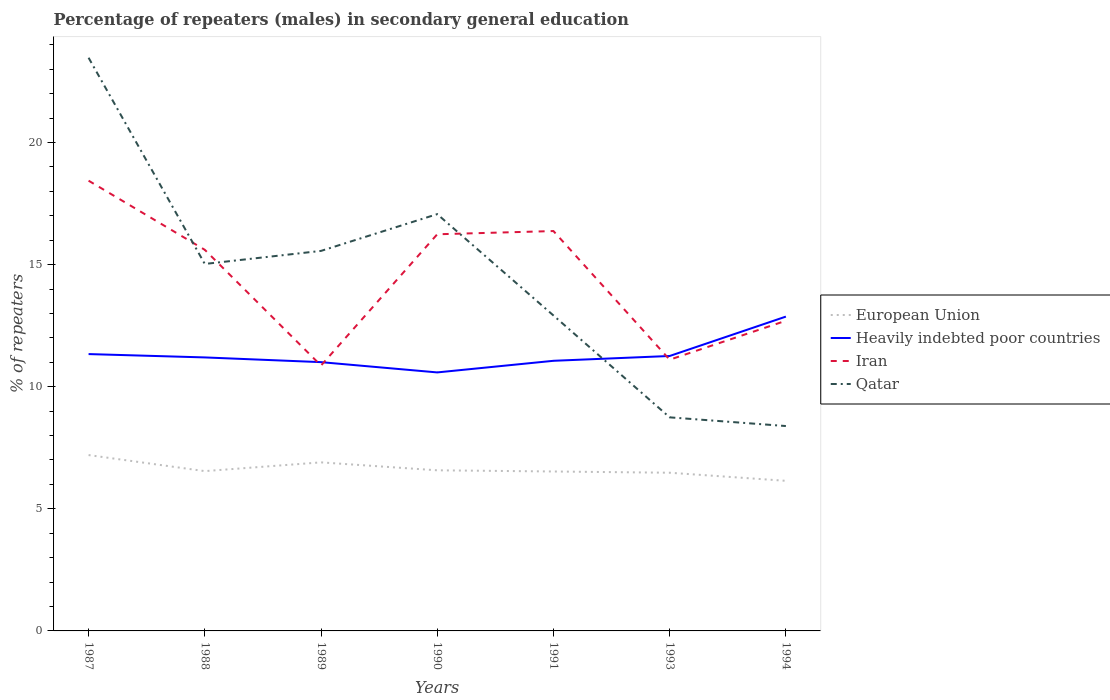How many different coloured lines are there?
Offer a very short reply. 4. Is the number of lines equal to the number of legend labels?
Make the answer very short. Yes. Across all years, what is the maximum percentage of male repeaters in Heavily indebted poor countries?
Give a very brief answer. 10.58. What is the total percentage of male repeaters in Heavily indebted poor countries in the graph?
Your answer should be very brief. 0.33. What is the difference between the highest and the second highest percentage of male repeaters in Qatar?
Offer a terse response. 15.08. What is the difference between the highest and the lowest percentage of male repeaters in Heavily indebted poor countries?
Your answer should be compact. 2. Is the percentage of male repeaters in Iran strictly greater than the percentage of male repeaters in Heavily indebted poor countries over the years?
Make the answer very short. No. What is the difference between two consecutive major ticks on the Y-axis?
Give a very brief answer. 5. Does the graph contain any zero values?
Your response must be concise. No. Where does the legend appear in the graph?
Provide a succinct answer. Center right. How many legend labels are there?
Provide a short and direct response. 4. How are the legend labels stacked?
Your answer should be compact. Vertical. What is the title of the graph?
Your response must be concise. Percentage of repeaters (males) in secondary general education. What is the label or title of the Y-axis?
Your answer should be compact. % of repeaters. What is the % of repeaters in European Union in 1987?
Keep it short and to the point. 7.2. What is the % of repeaters of Heavily indebted poor countries in 1987?
Give a very brief answer. 11.34. What is the % of repeaters in Iran in 1987?
Your response must be concise. 18.44. What is the % of repeaters of Qatar in 1987?
Ensure brevity in your answer.  23.47. What is the % of repeaters of European Union in 1988?
Your answer should be compact. 6.54. What is the % of repeaters in Heavily indebted poor countries in 1988?
Provide a short and direct response. 11.2. What is the % of repeaters of Iran in 1988?
Offer a very short reply. 15.61. What is the % of repeaters of Qatar in 1988?
Your response must be concise. 15.03. What is the % of repeaters in European Union in 1989?
Offer a very short reply. 6.9. What is the % of repeaters of Heavily indebted poor countries in 1989?
Offer a very short reply. 11.01. What is the % of repeaters in Iran in 1989?
Keep it short and to the point. 10.87. What is the % of repeaters in Qatar in 1989?
Provide a succinct answer. 15.56. What is the % of repeaters of European Union in 1990?
Provide a succinct answer. 6.58. What is the % of repeaters of Heavily indebted poor countries in 1990?
Your response must be concise. 10.58. What is the % of repeaters of Iran in 1990?
Ensure brevity in your answer.  16.24. What is the % of repeaters in Qatar in 1990?
Ensure brevity in your answer.  17.07. What is the % of repeaters of European Union in 1991?
Provide a succinct answer. 6.53. What is the % of repeaters of Heavily indebted poor countries in 1991?
Provide a succinct answer. 11.06. What is the % of repeaters in Iran in 1991?
Make the answer very short. 16.37. What is the % of repeaters of Qatar in 1991?
Your answer should be very brief. 12.92. What is the % of repeaters in European Union in 1993?
Ensure brevity in your answer.  6.48. What is the % of repeaters of Heavily indebted poor countries in 1993?
Offer a very short reply. 11.26. What is the % of repeaters in Iran in 1993?
Ensure brevity in your answer.  11.11. What is the % of repeaters in Qatar in 1993?
Offer a very short reply. 8.74. What is the % of repeaters in European Union in 1994?
Keep it short and to the point. 6.15. What is the % of repeaters in Heavily indebted poor countries in 1994?
Ensure brevity in your answer.  12.87. What is the % of repeaters in Iran in 1994?
Your answer should be compact. 12.7. What is the % of repeaters in Qatar in 1994?
Keep it short and to the point. 8.39. Across all years, what is the maximum % of repeaters in European Union?
Your answer should be very brief. 7.2. Across all years, what is the maximum % of repeaters of Heavily indebted poor countries?
Your answer should be very brief. 12.87. Across all years, what is the maximum % of repeaters of Iran?
Provide a succinct answer. 18.44. Across all years, what is the maximum % of repeaters in Qatar?
Ensure brevity in your answer.  23.47. Across all years, what is the minimum % of repeaters in European Union?
Provide a succinct answer. 6.15. Across all years, what is the minimum % of repeaters in Heavily indebted poor countries?
Offer a terse response. 10.58. Across all years, what is the minimum % of repeaters of Iran?
Ensure brevity in your answer.  10.87. Across all years, what is the minimum % of repeaters of Qatar?
Offer a terse response. 8.39. What is the total % of repeaters in European Union in the graph?
Provide a succinct answer. 46.37. What is the total % of repeaters in Heavily indebted poor countries in the graph?
Provide a short and direct response. 79.31. What is the total % of repeaters of Iran in the graph?
Your answer should be compact. 101.33. What is the total % of repeaters in Qatar in the graph?
Make the answer very short. 101.17. What is the difference between the % of repeaters in European Union in 1987 and that in 1988?
Your answer should be compact. 0.66. What is the difference between the % of repeaters in Heavily indebted poor countries in 1987 and that in 1988?
Offer a terse response. 0.14. What is the difference between the % of repeaters of Iran in 1987 and that in 1988?
Your answer should be compact. 2.83. What is the difference between the % of repeaters in Qatar in 1987 and that in 1988?
Your answer should be compact. 8.44. What is the difference between the % of repeaters of European Union in 1987 and that in 1989?
Offer a very short reply. 0.3. What is the difference between the % of repeaters of Heavily indebted poor countries in 1987 and that in 1989?
Make the answer very short. 0.33. What is the difference between the % of repeaters of Iran in 1987 and that in 1989?
Your answer should be compact. 7.57. What is the difference between the % of repeaters in Qatar in 1987 and that in 1989?
Keep it short and to the point. 7.91. What is the difference between the % of repeaters of European Union in 1987 and that in 1990?
Make the answer very short. 0.62. What is the difference between the % of repeaters of Heavily indebted poor countries in 1987 and that in 1990?
Offer a terse response. 0.75. What is the difference between the % of repeaters in Iran in 1987 and that in 1990?
Ensure brevity in your answer.  2.19. What is the difference between the % of repeaters in Qatar in 1987 and that in 1990?
Offer a very short reply. 6.4. What is the difference between the % of repeaters of European Union in 1987 and that in 1991?
Provide a short and direct response. 0.67. What is the difference between the % of repeaters in Heavily indebted poor countries in 1987 and that in 1991?
Your answer should be compact. 0.28. What is the difference between the % of repeaters of Iran in 1987 and that in 1991?
Give a very brief answer. 2.06. What is the difference between the % of repeaters of Qatar in 1987 and that in 1991?
Make the answer very short. 10.55. What is the difference between the % of repeaters of European Union in 1987 and that in 1993?
Provide a succinct answer. 0.72. What is the difference between the % of repeaters in Heavily indebted poor countries in 1987 and that in 1993?
Give a very brief answer. 0.08. What is the difference between the % of repeaters of Iran in 1987 and that in 1993?
Offer a very short reply. 7.33. What is the difference between the % of repeaters of Qatar in 1987 and that in 1993?
Make the answer very short. 14.72. What is the difference between the % of repeaters in European Union in 1987 and that in 1994?
Provide a succinct answer. 1.05. What is the difference between the % of repeaters of Heavily indebted poor countries in 1987 and that in 1994?
Provide a succinct answer. -1.53. What is the difference between the % of repeaters in Iran in 1987 and that in 1994?
Your answer should be compact. 5.74. What is the difference between the % of repeaters of Qatar in 1987 and that in 1994?
Give a very brief answer. 15.08. What is the difference between the % of repeaters in European Union in 1988 and that in 1989?
Make the answer very short. -0.36. What is the difference between the % of repeaters in Heavily indebted poor countries in 1988 and that in 1989?
Give a very brief answer. 0.19. What is the difference between the % of repeaters of Iran in 1988 and that in 1989?
Your answer should be very brief. 4.74. What is the difference between the % of repeaters in Qatar in 1988 and that in 1989?
Give a very brief answer. -0.53. What is the difference between the % of repeaters of European Union in 1988 and that in 1990?
Provide a succinct answer. -0.03. What is the difference between the % of repeaters of Heavily indebted poor countries in 1988 and that in 1990?
Make the answer very short. 0.61. What is the difference between the % of repeaters in Iran in 1988 and that in 1990?
Offer a terse response. -0.64. What is the difference between the % of repeaters of Qatar in 1988 and that in 1990?
Make the answer very short. -2.04. What is the difference between the % of repeaters in European Union in 1988 and that in 1991?
Your answer should be compact. 0.02. What is the difference between the % of repeaters of Heavily indebted poor countries in 1988 and that in 1991?
Make the answer very short. 0.14. What is the difference between the % of repeaters in Iran in 1988 and that in 1991?
Ensure brevity in your answer.  -0.77. What is the difference between the % of repeaters of Qatar in 1988 and that in 1991?
Make the answer very short. 2.11. What is the difference between the % of repeaters of European Union in 1988 and that in 1993?
Your response must be concise. 0.07. What is the difference between the % of repeaters in Heavily indebted poor countries in 1988 and that in 1993?
Offer a terse response. -0.06. What is the difference between the % of repeaters in Iran in 1988 and that in 1993?
Your answer should be compact. 4.5. What is the difference between the % of repeaters of Qatar in 1988 and that in 1993?
Keep it short and to the point. 6.28. What is the difference between the % of repeaters of European Union in 1988 and that in 1994?
Your answer should be very brief. 0.4. What is the difference between the % of repeaters of Heavily indebted poor countries in 1988 and that in 1994?
Provide a short and direct response. -1.67. What is the difference between the % of repeaters of Iran in 1988 and that in 1994?
Make the answer very short. 2.9. What is the difference between the % of repeaters in Qatar in 1988 and that in 1994?
Your response must be concise. 6.64. What is the difference between the % of repeaters of European Union in 1989 and that in 1990?
Make the answer very short. 0.33. What is the difference between the % of repeaters of Heavily indebted poor countries in 1989 and that in 1990?
Ensure brevity in your answer.  0.42. What is the difference between the % of repeaters of Iran in 1989 and that in 1990?
Your response must be concise. -5.38. What is the difference between the % of repeaters in Qatar in 1989 and that in 1990?
Give a very brief answer. -1.51. What is the difference between the % of repeaters in European Union in 1989 and that in 1991?
Provide a short and direct response. 0.37. What is the difference between the % of repeaters of Heavily indebted poor countries in 1989 and that in 1991?
Provide a short and direct response. -0.06. What is the difference between the % of repeaters of Iran in 1989 and that in 1991?
Offer a terse response. -5.51. What is the difference between the % of repeaters in Qatar in 1989 and that in 1991?
Make the answer very short. 2.64. What is the difference between the % of repeaters of European Union in 1989 and that in 1993?
Provide a short and direct response. 0.42. What is the difference between the % of repeaters of Heavily indebted poor countries in 1989 and that in 1993?
Give a very brief answer. -0.25. What is the difference between the % of repeaters in Iran in 1989 and that in 1993?
Ensure brevity in your answer.  -0.24. What is the difference between the % of repeaters in Qatar in 1989 and that in 1993?
Provide a short and direct response. 6.82. What is the difference between the % of repeaters of European Union in 1989 and that in 1994?
Keep it short and to the point. 0.76. What is the difference between the % of repeaters of Heavily indebted poor countries in 1989 and that in 1994?
Provide a short and direct response. -1.86. What is the difference between the % of repeaters of Iran in 1989 and that in 1994?
Keep it short and to the point. -1.83. What is the difference between the % of repeaters of Qatar in 1989 and that in 1994?
Provide a short and direct response. 7.17. What is the difference between the % of repeaters of European Union in 1990 and that in 1991?
Ensure brevity in your answer.  0.05. What is the difference between the % of repeaters in Heavily indebted poor countries in 1990 and that in 1991?
Give a very brief answer. -0.48. What is the difference between the % of repeaters of Iran in 1990 and that in 1991?
Provide a succinct answer. -0.13. What is the difference between the % of repeaters of Qatar in 1990 and that in 1991?
Keep it short and to the point. 4.15. What is the difference between the % of repeaters in European Union in 1990 and that in 1993?
Ensure brevity in your answer.  0.1. What is the difference between the % of repeaters of Heavily indebted poor countries in 1990 and that in 1993?
Provide a short and direct response. -0.67. What is the difference between the % of repeaters of Iran in 1990 and that in 1993?
Offer a terse response. 5.14. What is the difference between the % of repeaters of Qatar in 1990 and that in 1993?
Offer a terse response. 8.32. What is the difference between the % of repeaters in European Union in 1990 and that in 1994?
Give a very brief answer. 0.43. What is the difference between the % of repeaters in Heavily indebted poor countries in 1990 and that in 1994?
Provide a short and direct response. -2.29. What is the difference between the % of repeaters of Iran in 1990 and that in 1994?
Ensure brevity in your answer.  3.54. What is the difference between the % of repeaters in Qatar in 1990 and that in 1994?
Provide a succinct answer. 8.68. What is the difference between the % of repeaters in European Union in 1991 and that in 1993?
Keep it short and to the point. 0.05. What is the difference between the % of repeaters of Heavily indebted poor countries in 1991 and that in 1993?
Provide a succinct answer. -0.2. What is the difference between the % of repeaters of Iran in 1991 and that in 1993?
Your answer should be compact. 5.27. What is the difference between the % of repeaters in Qatar in 1991 and that in 1993?
Ensure brevity in your answer.  4.17. What is the difference between the % of repeaters of European Union in 1991 and that in 1994?
Offer a terse response. 0.38. What is the difference between the % of repeaters of Heavily indebted poor countries in 1991 and that in 1994?
Give a very brief answer. -1.81. What is the difference between the % of repeaters of Iran in 1991 and that in 1994?
Your answer should be very brief. 3.67. What is the difference between the % of repeaters in Qatar in 1991 and that in 1994?
Ensure brevity in your answer.  4.53. What is the difference between the % of repeaters in European Union in 1993 and that in 1994?
Give a very brief answer. 0.33. What is the difference between the % of repeaters in Heavily indebted poor countries in 1993 and that in 1994?
Make the answer very short. -1.61. What is the difference between the % of repeaters in Iran in 1993 and that in 1994?
Your answer should be very brief. -1.59. What is the difference between the % of repeaters in Qatar in 1993 and that in 1994?
Provide a succinct answer. 0.36. What is the difference between the % of repeaters in European Union in 1987 and the % of repeaters in Heavily indebted poor countries in 1988?
Make the answer very short. -4. What is the difference between the % of repeaters of European Union in 1987 and the % of repeaters of Iran in 1988?
Your answer should be very brief. -8.4. What is the difference between the % of repeaters of European Union in 1987 and the % of repeaters of Qatar in 1988?
Your answer should be compact. -7.83. What is the difference between the % of repeaters in Heavily indebted poor countries in 1987 and the % of repeaters in Iran in 1988?
Keep it short and to the point. -4.27. What is the difference between the % of repeaters of Heavily indebted poor countries in 1987 and the % of repeaters of Qatar in 1988?
Offer a terse response. -3.69. What is the difference between the % of repeaters of Iran in 1987 and the % of repeaters of Qatar in 1988?
Your answer should be compact. 3.41. What is the difference between the % of repeaters of European Union in 1987 and the % of repeaters of Heavily indebted poor countries in 1989?
Offer a very short reply. -3.8. What is the difference between the % of repeaters of European Union in 1987 and the % of repeaters of Iran in 1989?
Provide a short and direct response. -3.67. What is the difference between the % of repeaters in European Union in 1987 and the % of repeaters in Qatar in 1989?
Give a very brief answer. -8.36. What is the difference between the % of repeaters of Heavily indebted poor countries in 1987 and the % of repeaters of Iran in 1989?
Offer a very short reply. 0.47. What is the difference between the % of repeaters of Heavily indebted poor countries in 1987 and the % of repeaters of Qatar in 1989?
Offer a terse response. -4.22. What is the difference between the % of repeaters in Iran in 1987 and the % of repeaters in Qatar in 1989?
Ensure brevity in your answer.  2.88. What is the difference between the % of repeaters in European Union in 1987 and the % of repeaters in Heavily indebted poor countries in 1990?
Ensure brevity in your answer.  -3.38. What is the difference between the % of repeaters in European Union in 1987 and the % of repeaters in Iran in 1990?
Offer a very short reply. -9.04. What is the difference between the % of repeaters in European Union in 1987 and the % of repeaters in Qatar in 1990?
Keep it short and to the point. -9.87. What is the difference between the % of repeaters in Heavily indebted poor countries in 1987 and the % of repeaters in Iran in 1990?
Provide a succinct answer. -4.91. What is the difference between the % of repeaters of Heavily indebted poor countries in 1987 and the % of repeaters of Qatar in 1990?
Make the answer very short. -5.73. What is the difference between the % of repeaters in Iran in 1987 and the % of repeaters in Qatar in 1990?
Make the answer very short. 1.37. What is the difference between the % of repeaters in European Union in 1987 and the % of repeaters in Heavily indebted poor countries in 1991?
Provide a short and direct response. -3.86. What is the difference between the % of repeaters of European Union in 1987 and the % of repeaters of Iran in 1991?
Your answer should be compact. -9.17. What is the difference between the % of repeaters in European Union in 1987 and the % of repeaters in Qatar in 1991?
Offer a terse response. -5.72. What is the difference between the % of repeaters of Heavily indebted poor countries in 1987 and the % of repeaters of Iran in 1991?
Your response must be concise. -5.04. What is the difference between the % of repeaters in Heavily indebted poor countries in 1987 and the % of repeaters in Qatar in 1991?
Provide a short and direct response. -1.58. What is the difference between the % of repeaters of Iran in 1987 and the % of repeaters of Qatar in 1991?
Provide a short and direct response. 5.52. What is the difference between the % of repeaters in European Union in 1987 and the % of repeaters in Heavily indebted poor countries in 1993?
Provide a short and direct response. -4.06. What is the difference between the % of repeaters in European Union in 1987 and the % of repeaters in Iran in 1993?
Provide a short and direct response. -3.9. What is the difference between the % of repeaters of European Union in 1987 and the % of repeaters of Qatar in 1993?
Give a very brief answer. -1.54. What is the difference between the % of repeaters in Heavily indebted poor countries in 1987 and the % of repeaters in Iran in 1993?
Keep it short and to the point. 0.23. What is the difference between the % of repeaters of Heavily indebted poor countries in 1987 and the % of repeaters of Qatar in 1993?
Offer a terse response. 2.59. What is the difference between the % of repeaters of Iran in 1987 and the % of repeaters of Qatar in 1993?
Ensure brevity in your answer.  9.69. What is the difference between the % of repeaters in European Union in 1987 and the % of repeaters in Heavily indebted poor countries in 1994?
Offer a terse response. -5.67. What is the difference between the % of repeaters in European Union in 1987 and the % of repeaters in Iran in 1994?
Your answer should be compact. -5.5. What is the difference between the % of repeaters of European Union in 1987 and the % of repeaters of Qatar in 1994?
Your answer should be compact. -1.19. What is the difference between the % of repeaters in Heavily indebted poor countries in 1987 and the % of repeaters in Iran in 1994?
Ensure brevity in your answer.  -1.36. What is the difference between the % of repeaters of Heavily indebted poor countries in 1987 and the % of repeaters of Qatar in 1994?
Make the answer very short. 2.95. What is the difference between the % of repeaters in Iran in 1987 and the % of repeaters in Qatar in 1994?
Your answer should be compact. 10.05. What is the difference between the % of repeaters in European Union in 1988 and the % of repeaters in Heavily indebted poor countries in 1989?
Give a very brief answer. -4.46. What is the difference between the % of repeaters in European Union in 1988 and the % of repeaters in Iran in 1989?
Your answer should be compact. -4.32. What is the difference between the % of repeaters in European Union in 1988 and the % of repeaters in Qatar in 1989?
Ensure brevity in your answer.  -9.02. What is the difference between the % of repeaters of Heavily indebted poor countries in 1988 and the % of repeaters of Iran in 1989?
Your response must be concise. 0.33. What is the difference between the % of repeaters of Heavily indebted poor countries in 1988 and the % of repeaters of Qatar in 1989?
Make the answer very short. -4.36. What is the difference between the % of repeaters in Iran in 1988 and the % of repeaters in Qatar in 1989?
Make the answer very short. 0.04. What is the difference between the % of repeaters in European Union in 1988 and the % of repeaters in Heavily indebted poor countries in 1990?
Keep it short and to the point. -4.04. What is the difference between the % of repeaters of European Union in 1988 and the % of repeaters of Iran in 1990?
Keep it short and to the point. -9.7. What is the difference between the % of repeaters of European Union in 1988 and the % of repeaters of Qatar in 1990?
Ensure brevity in your answer.  -10.52. What is the difference between the % of repeaters in Heavily indebted poor countries in 1988 and the % of repeaters in Iran in 1990?
Provide a succinct answer. -5.04. What is the difference between the % of repeaters of Heavily indebted poor countries in 1988 and the % of repeaters of Qatar in 1990?
Your answer should be very brief. -5.87. What is the difference between the % of repeaters in Iran in 1988 and the % of repeaters in Qatar in 1990?
Your response must be concise. -1.46. What is the difference between the % of repeaters in European Union in 1988 and the % of repeaters in Heavily indebted poor countries in 1991?
Offer a terse response. -4.52. What is the difference between the % of repeaters in European Union in 1988 and the % of repeaters in Iran in 1991?
Your answer should be very brief. -9.83. What is the difference between the % of repeaters in European Union in 1988 and the % of repeaters in Qatar in 1991?
Your answer should be very brief. -6.37. What is the difference between the % of repeaters in Heavily indebted poor countries in 1988 and the % of repeaters in Iran in 1991?
Offer a terse response. -5.17. What is the difference between the % of repeaters in Heavily indebted poor countries in 1988 and the % of repeaters in Qatar in 1991?
Your response must be concise. -1.72. What is the difference between the % of repeaters in Iran in 1988 and the % of repeaters in Qatar in 1991?
Your response must be concise. 2.69. What is the difference between the % of repeaters in European Union in 1988 and the % of repeaters in Heavily indebted poor countries in 1993?
Provide a short and direct response. -4.71. What is the difference between the % of repeaters of European Union in 1988 and the % of repeaters of Iran in 1993?
Keep it short and to the point. -4.56. What is the difference between the % of repeaters of European Union in 1988 and the % of repeaters of Qatar in 1993?
Your answer should be compact. -2.2. What is the difference between the % of repeaters in Heavily indebted poor countries in 1988 and the % of repeaters in Iran in 1993?
Provide a short and direct response. 0.09. What is the difference between the % of repeaters in Heavily indebted poor countries in 1988 and the % of repeaters in Qatar in 1993?
Keep it short and to the point. 2.45. What is the difference between the % of repeaters in Iran in 1988 and the % of repeaters in Qatar in 1993?
Your response must be concise. 6.86. What is the difference between the % of repeaters in European Union in 1988 and the % of repeaters in Heavily indebted poor countries in 1994?
Keep it short and to the point. -6.33. What is the difference between the % of repeaters of European Union in 1988 and the % of repeaters of Iran in 1994?
Make the answer very short. -6.16. What is the difference between the % of repeaters in European Union in 1988 and the % of repeaters in Qatar in 1994?
Ensure brevity in your answer.  -1.85. What is the difference between the % of repeaters in Heavily indebted poor countries in 1988 and the % of repeaters in Iran in 1994?
Provide a succinct answer. -1.5. What is the difference between the % of repeaters of Heavily indebted poor countries in 1988 and the % of repeaters of Qatar in 1994?
Keep it short and to the point. 2.81. What is the difference between the % of repeaters of Iran in 1988 and the % of repeaters of Qatar in 1994?
Your answer should be compact. 7.22. What is the difference between the % of repeaters of European Union in 1989 and the % of repeaters of Heavily indebted poor countries in 1990?
Give a very brief answer. -3.68. What is the difference between the % of repeaters in European Union in 1989 and the % of repeaters in Iran in 1990?
Give a very brief answer. -9.34. What is the difference between the % of repeaters of European Union in 1989 and the % of repeaters of Qatar in 1990?
Provide a short and direct response. -10.16. What is the difference between the % of repeaters of Heavily indebted poor countries in 1989 and the % of repeaters of Iran in 1990?
Ensure brevity in your answer.  -5.24. What is the difference between the % of repeaters in Heavily indebted poor countries in 1989 and the % of repeaters in Qatar in 1990?
Make the answer very short. -6.06. What is the difference between the % of repeaters of Iran in 1989 and the % of repeaters of Qatar in 1990?
Your answer should be very brief. -6.2. What is the difference between the % of repeaters of European Union in 1989 and the % of repeaters of Heavily indebted poor countries in 1991?
Ensure brevity in your answer.  -4.16. What is the difference between the % of repeaters of European Union in 1989 and the % of repeaters of Iran in 1991?
Your response must be concise. -9.47. What is the difference between the % of repeaters in European Union in 1989 and the % of repeaters in Qatar in 1991?
Provide a succinct answer. -6.01. What is the difference between the % of repeaters in Heavily indebted poor countries in 1989 and the % of repeaters in Iran in 1991?
Give a very brief answer. -5.37. What is the difference between the % of repeaters in Heavily indebted poor countries in 1989 and the % of repeaters in Qatar in 1991?
Your answer should be compact. -1.91. What is the difference between the % of repeaters of Iran in 1989 and the % of repeaters of Qatar in 1991?
Make the answer very short. -2.05. What is the difference between the % of repeaters of European Union in 1989 and the % of repeaters of Heavily indebted poor countries in 1993?
Offer a very short reply. -4.36. What is the difference between the % of repeaters in European Union in 1989 and the % of repeaters in Iran in 1993?
Provide a succinct answer. -4.2. What is the difference between the % of repeaters in European Union in 1989 and the % of repeaters in Qatar in 1993?
Offer a terse response. -1.84. What is the difference between the % of repeaters of Heavily indebted poor countries in 1989 and the % of repeaters of Iran in 1993?
Your answer should be compact. -0.1. What is the difference between the % of repeaters of Heavily indebted poor countries in 1989 and the % of repeaters of Qatar in 1993?
Your answer should be very brief. 2.26. What is the difference between the % of repeaters of Iran in 1989 and the % of repeaters of Qatar in 1993?
Your answer should be very brief. 2.12. What is the difference between the % of repeaters of European Union in 1989 and the % of repeaters of Heavily indebted poor countries in 1994?
Give a very brief answer. -5.97. What is the difference between the % of repeaters of European Union in 1989 and the % of repeaters of Iran in 1994?
Your response must be concise. -5.8. What is the difference between the % of repeaters in European Union in 1989 and the % of repeaters in Qatar in 1994?
Ensure brevity in your answer.  -1.49. What is the difference between the % of repeaters of Heavily indebted poor countries in 1989 and the % of repeaters of Iran in 1994?
Your answer should be very brief. -1.7. What is the difference between the % of repeaters of Heavily indebted poor countries in 1989 and the % of repeaters of Qatar in 1994?
Provide a succinct answer. 2.62. What is the difference between the % of repeaters of Iran in 1989 and the % of repeaters of Qatar in 1994?
Your answer should be very brief. 2.48. What is the difference between the % of repeaters of European Union in 1990 and the % of repeaters of Heavily indebted poor countries in 1991?
Provide a short and direct response. -4.48. What is the difference between the % of repeaters of European Union in 1990 and the % of repeaters of Iran in 1991?
Provide a succinct answer. -9.8. What is the difference between the % of repeaters in European Union in 1990 and the % of repeaters in Qatar in 1991?
Ensure brevity in your answer.  -6.34. What is the difference between the % of repeaters of Heavily indebted poor countries in 1990 and the % of repeaters of Iran in 1991?
Give a very brief answer. -5.79. What is the difference between the % of repeaters of Heavily indebted poor countries in 1990 and the % of repeaters of Qatar in 1991?
Offer a very short reply. -2.33. What is the difference between the % of repeaters of Iran in 1990 and the % of repeaters of Qatar in 1991?
Give a very brief answer. 3.33. What is the difference between the % of repeaters of European Union in 1990 and the % of repeaters of Heavily indebted poor countries in 1993?
Provide a short and direct response. -4.68. What is the difference between the % of repeaters in European Union in 1990 and the % of repeaters in Iran in 1993?
Ensure brevity in your answer.  -4.53. What is the difference between the % of repeaters of European Union in 1990 and the % of repeaters of Qatar in 1993?
Your answer should be compact. -2.17. What is the difference between the % of repeaters of Heavily indebted poor countries in 1990 and the % of repeaters of Iran in 1993?
Provide a succinct answer. -0.52. What is the difference between the % of repeaters in Heavily indebted poor countries in 1990 and the % of repeaters in Qatar in 1993?
Your answer should be compact. 1.84. What is the difference between the % of repeaters in Iran in 1990 and the % of repeaters in Qatar in 1993?
Make the answer very short. 7.5. What is the difference between the % of repeaters of European Union in 1990 and the % of repeaters of Heavily indebted poor countries in 1994?
Give a very brief answer. -6.29. What is the difference between the % of repeaters of European Union in 1990 and the % of repeaters of Iran in 1994?
Offer a terse response. -6.12. What is the difference between the % of repeaters in European Union in 1990 and the % of repeaters in Qatar in 1994?
Provide a short and direct response. -1.81. What is the difference between the % of repeaters of Heavily indebted poor countries in 1990 and the % of repeaters of Iran in 1994?
Keep it short and to the point. -2.12. What is the difference between the % of repeaters of Heavily indebted poor countries in 1990 and the % of repeaters of Qatar in 1994?
Offer a very short reply. 2.2. What is the difference between the % of repeaters in Iran in 1990 and the % of repeaters in Qatar in 1994?
Your answer should be compact. 7.85. What is the difference between the % of repeaters in European Union in 1991 and the % of repeaters in Heavily indebted poor countries in 1993?
Give a very brief answer. -4.73. What is the difference between the % of repeaters of European Union in 1991 and the % of repeaters of Iran in 1993?
Your response must be concise. -4.58. What is the difference between the % of repeaters in European Union in 1991 and the % of repeaters in Qatar in 1993?
Offer a terse response. -2.22. What is the difference between the % of repeaters in Heavily indebted poor countries in 1991 and the % of repeaters in Iran in 1993?
Offer a terse response. -0.05. What is the difference between the % of repeaters in Heavily indebted poor countries in 1991 and the % of repeaters in Qatar in 1993?
Give a very brief answer. 2.32. What is the difference between the % of repeaters in Iran in 1991 and the % of repeaters in Qatar in 1993?
Provide a succinct answer. 7.63. What is the difference between the % of repeaters in European Union in 1991 and the % of repeaters in Heavily indebted poor countries in 1994?
Provide a succinct answer. -6.34. What is the difference between the % of repeaters of European Union in 1991 and the % of repeaters of Iran in 1994?
Make the answer very short. -6.17. What is the difference between the % of repeaters in European Union in 1991 and the % of repeaters in Qatar in 1994?
Provide a short and direct response. -1.86. What is the difference between the % of repeaters of Heavily indebted poor countries in 1991 and the % of repeaters of Iran in 1994?
Give a very brief answer. -1.64. What is the difference between the % of repeaters in Heavily indebted poor countries in 1991 and the % of repeaters in Qatar in 1994?
Give a very brief answer. 2.67. What is the difference between the % of repeaters of Iran in 1991 and the % of repeaters of Qatar in 1994?
Your response must be concise. 7.98. What is the difference between the % of repeaters in European Union in 1993 and the % of repeaters in Heavily indebted poor countries in 1994?
Your answer should be compact. -6.39. What is the difference between the % of repeaters in European Union in 1993 and the % of repeaters in Iran in 1994?
Your answer should be compact. -6.22. What is the difference between the % of repeaters in European Union in 1993 and the % of repeaters in Qatar in 1994?
Keep it short and to the point. -1.91. What is the difference between the % of repeaters in Heavily indebted poor countries in 1993 and the % of repeaters in Iran in 1994?
Your response must be concise. -1.44. What is the difference between the % of repeaters of Heavily indebted poor countries in 1993 and the % of repeaters of Qatar in 1994?
Ensure brevity in your answer.  2.87. What is the difference between the % of repeaters of Iran in 1993 and the % of repeaters of Qatar in 1994?
Offer a terse response. 2.72. What is the average % of repeaters in European Union per year?
Provide a short and direct response. 6.62. What is the average % of repeaters of Heavily indebted poor countries per year?
Keep it short and to the point. 11.33. What is the average % of repeaters of Iran per year?
Provide a succinct answer. 14.48. What is the average % of repeaters of Qatar per year?
Ensure brevity in your answer.  14.45. In the year 1987, what is the difference between the % of repeaters in European Union and % of repeaters in Heavily indebted poor countries?
Provide a short and direct response. -4.13. In the year 1987, what is the difference between the % of repeaters in European Union and % of repeaters in Iran?
Provide a succinct answer. -11.23. In the year 1987, what is the difference between the % of repeaters of European Union and % of repeaters of Qatar?
Keep it short and to the point. -16.27. In the year 1987, what is the difference between the % of repeaters of Heavily indebted poor countries and % of repeaters of Iran?
Offer a terse response. -7.1. In the year 1987, what is the difference between the % of repeaters in Heavily indebted poor countries and % of repeaters in Qatar?
Provide a succinct answer. -12.13. In the year 1987, what is the difference between the % of repeaters in Iran and % of repeaters in Qatar?
Provide a short and direct response. -5.03. In the year 1988, what is the difference between the % of repeaters in European Union and % of repeaters in Heavily indebted poor countries?
Provide a short and direct response. -4.66. In the year 1988, what is the difference between the % of repeaters in European Union and % of repeaters in Iran?
Provide a succinct answer. -9.06. In the year 1988, what is the difference between the % of repeaters in European Union and % of repeaters in Qatar?
Ensure brevity in your answer.  -8.48. In the year 1988, what is the difference between the % of repeaters in Heavily indebted poor countries and % of repeaters in Iran?
Offer a very short reply. -4.41. In the year 1988, what is the difference between the % of repeaters of Heavily indebted poor countries and % of repeaters of Qatar?
Make the answer very short. -3.83. In the year 1988, what is the difference between the % of repeaters in Iran and % of repeaters in Qatar?
Your response must be concise. 0.58. In the year 1989, what is the difference between the % of repeaters in European Union and % of repeaters in Heavily indebted poor countries?
Provide a succinct answer. -4.1. In the year 1989, what is the difference between the % of repeaters of European Union and % of repeaters of Iran?
Make the answer very short. -3.96. In the year 1989, what is the difference between the % of repeaters of European Union and % of repeaters of Qatar?
Your response must be concise. -8.66. In the year 1989, what is the difference between the % of repeaters in Heavily indebted poor countries and % of repeaters in Iran?
Offer a very short reply. 0.14. In the year 1989, what is the difference between the % of repeaters in Heavily indebted poor countries and % of repeaters in Qatar?
Ensure brevity in your answer.  -4.56. In the year 1989, what is the difference between the % of repeaters of Iran and % of repeaters of Qatar?
Give a very brief answer. -4.69. In the year 1990, what is the difference between the % of repeaters in European Union and % of repeaters in Heavily indebted poor countries?
Offer a terse response. -4.01. In the year 1990, what is the difference between the % of repeaters in European Union and % of repeaters in Iran?
Offer a very short reply. -9.66. In the year 1990, what is the difference between the % of repeaters of European Union and % of repeaters of Qatar?
Provide a short and direct response. -10.49. In the year 1990, what is the difference between the % of repeaters in Heavily indebted poor countries and % of repeaters in Iran?
Your answer should be compact. -5.66. In the year 1990, what is the difference between the % of repeaters of Heavily indebted poor countries and % of repeaters of Qatar?
Offer a terse response. -6.48. In the year 1990, what is the difference between the % of repeaters of Iran and % of repeaters of Qatar?
Offer a terse response. -0.82. In the year 1991, what is the difference between the % of repeaters of European Union and % of repeaters of Heavily indebted poor countries?
Your answer should be very brief. -4.53. In the year 1991, what is the difference between the % of repeaters of European Union and % of repeaters of Iran?
Ensure brevity in your answer.  -9.84. In the year 1991, what is the difference between the % of repeaters in European Union and % of repeaters in Qatar?
Ensure brevity in your answer.  -6.39. In the year 1991, what is the difference between the % of repeaters of Heavily indebted poor countries and % of repeaters of Iran?
Give a very brief answer. -5.31. In the year 1991, what is the difference between the % of repeaters of Heavily indebted poor countries and % of repeaters of Qatar?
Your answer should be very brief. -1.86. In the year 1991, what is the difference between the % of repeaters of Iran and % of repeaters of Qatar?
Your response must be concise. 3.46. In the year 1993, what is the difference between the % of repeaters in European Union and % of repeaters in Heavily indebted poor countries?
Make the answer very short. -4.78. In the year 1993, what is the difference between the % of repeaters in European Union and % of repeaters in Iran?
Give a very brief answer. -4.63. In the year 1993, what is the difference between the % of repeaters in European Union and % of repeaters in Qatar?
Make the answer very short. -2.27. In the year 1993, what is the difference between the % of repeaters of Heavily indebted poor countries and % of repeaters of Iran?
Make the answer very short. 0.15. In the year 1993, what is the difference between the % of repeaters in Heavily indebted poor countries and % of repeaters in Qatar?
Give a very brief answer. 2.51. In the year 1993, what is the difference between the % of repeaters in Iran and % of repeaters in Qatar?
Your answer should be compact. 2.36. In the year 1994, what is the difference between the % of repeaters of European Union and % of repeaters of Heavily indebted poor countries?
Provide a short and direct response. -6.72. In the year 1994, what is the difference between the % of repeaters in European Union and % of repeaters in Iran?
Your response must be concise. -6.55. In the year 1994, what is the difference between the % of repeaters of European Union and % of repeaters of Qatar?
Provide a succinct answer. -2.24. In the year 1994, what is the difference between the % of repeaters of Heavily indebted poor countries and % of repeaters of Iran?
Your response must be concise. 0.17. In the year 1994, what is the difference between the % of repeaters of Heavily indebted poor countries and % of repeaters of Qatar?
Your answer should be very brief. 4.48. In the year 1994, what is the difference between the % of repeaters in Iran and % of repeaters in Qatar?
Your answer should be very brief. 4.31. What is the ratio of the % of repeaters of European Union in 1987 to that in 1988?
Give a very brief answer. 1.1. What is the ratio of the % of repeaters of Heavily indebted poor countries in 1987 to that in 1988?
Provide a short and direct response. 1.01. What is the ratio of the % of repeaters of Iran in 1987 to that in 1988?
Provide a short and direct response. 1.18. What is the ratio of the % of repeaters in Qatar in 1987 to that in 1988?
Your answer should be very brief. 1.56. What is the ratio of the % of repeaters of European Union in 1987 to that in 1989?
Your answer should be very brief. 1.04. What is the ratio of the % of repeaters of Heavily indebted poor countries in 1987 to that in 1989?
Provide a succinct answer. 1.03. What is the ratio of the % of repeaters in Iran in 1987 to that in 1989?
Keep it short and to the point. 1.7. What is the ratio of the % of repeaters of Qatar in 1987 to that in 1989?
Keep it short and to the point. 1.51. What is the ratio of the % of repeaters in European Union in 1987 to that in 1990?
Offer a very short reply. 1.09. What is the ratio of the % of repeaters of Heavily indebted poor countries in 1987 to that in 1990?
Your answer should be compact. 1.07. What is the ratio of the % of repeaters in Iran in 1987 to that in 1990?
Provide a short and direct response. 1.14. What is the ratio of the % of repeaters of Qatar in 1987 to that in 1990?
Offer a very short reply. 1.38. What is the ratio of the % of repeaters of European Union in 1987 to that in 1991?
Provide a short and direct response. 1.1. What is the ratio of the % of repeaters of Heavily indebted poor countries in 1987 to that in 1991?
Provide a short and direct response. 1.02. What is the ratio of the % of repeaters in Iran in 1987 to that in 1991?
Provide a short and direct response. 1.13. What is the ratio of the % of repeaters in Qatar in 1987 to that in 1991?
Give a very brief answer. 1.82. What is the ratio of the % of repeaters of European Union in 1987 to that in 1993?
Give a very brief answer. 1.11. What is the ratio of the % of repeaters in Heavily indebted poor countries in 1987 to that in 1993?
Provide a short and direct response. 1.01. What is the ratio of the % of repeaters in Iran in 1987 to that in 1993?
Make the answer very short. 1.66. What is the ratio of the % of repeaters of Qatar in 1987 to that in 1993?
Keep it short and to the point. 2.68. What is the ratio of the % of repeaters in European Union in 1987 to that in 1994?
Your answer should be compact. 1.17. What is the ratio of the % of repeaters of Heavily indebted poor countries in 1987 to that in 1994?
Keep it short and to the point. 0.88. What is the ratio of the % of repeaters of Iran in 1987 to that in 1994?
Keep it short and to the point. 1.45. What is the ratio of the % of repeaters of Qatar in 1987 to that in 1994?
Give a very brief answer. 2.8. What is the ratio of the % of repeaters in European Union in 1988 to that in 1989?
Your response must be concise. 0.95. What is the ratio of the % of repeaters of Heavily indebted poor countries in 1988 to that in 1989?
Provide a short and direct response. 1.02. What is the ratio of the % of repeaters of Iran in 1988 to that in 1989?
Your answer should be compact. 1.44. What is the ratio of the % of repeaters in Qatar in 1988 to that in 1989?
Make the answer very short. 0.97. What is the ratio of the % of repeaters in European Union in 1988 to that in 1990?
Provide a succinct answer. 0.99. What is the ratio of the % of repeaters of Heavily indebted poor countries in 1988 to that in 1990?
Offer a terse response. 1.06. What is the ratio of the % of repeaters of Iran in 1988 to that in 1990?
Make the answer very short. 0.96. What is the ratio of the % of repeaters in Qatar in 1988 to that in 1990?
Offer a terse response. 0.88. What is the ratio of the % of repeaters in European Union in 1988 to that in 1991?
Offer a terse response. 1. What is the ratio of the % of repeaters of Heavily indebted poor countries in 1988 to that in 1991?
Provide a succinct answer. 1.01. What is the ratio of the % of repeaters in Iran in 1988 to that in 1991?
Provide a succinct answer. 0.95. What is the ratio of the % of repeaters of Qatar in 1988 to that in 1991?
Your answer should be compact. 1.16. What is the ratio of the % of repeaters of European Union in 1988 to that in 1993?
Give a very brief answer. 1.01. What is the ratio of the % of repeaters in Heavily indebted poor countries in 1988 to that in 1993?
Provide a succinct answer. 0.99. What is the ratio of the % of repeaters in Iran in 1988 to that in 1993?
Offer a terse response. 1.41. What is the ratio of the % of repeaters in Qatar in 1988 to that in 1993?
Your response must be concise. 1.72. What is the ratio of the % of repeaters of European Union in 1988 to that in 1994?
Offer a terse response. 1.06. What is the ratio of the % of repeaters of Heavily indebted poor countries in 1988 to that in 1994?
Offer a very short reply. 0.87. What is the ratio of the % of repeaters of Iran in 1988 to that in 1994?
Your answer should be very brief. 1.23. What is the ratio of the % of repeaters in Qatar in 1988 to that in 1994?
Ensure brevity in your answer.  1.79. What is the ratio of the % of repeaters in European Union in 1989 to that in 1990?
Your answer should be compact. 1.05. What is the ratio of the % of repeaters of Heavily indebted poor countries in 1989 to that in 1990?
Make the answer very short. 1.04. What is the ratio of the % of repeaters of Iran in 1989 to that in 1990?
Provide a short and direct response. 0.67. What is the ratio of the % of repeaters of Qatar in 1989 to that in 1990?
Ensure brevity in your answer.  0.91. What is the ratio of the % of repeaters of European Union in 1989 to that in 1991?
Make the answer very short. 1.06. What is the ratio of the % of repeaters in Iran in 1989 to that in 1991?
Your answer should be compact. 0.66. What is the ratio of the % of repeaters in Qatar in 1989 to that in 1991?
Keep it short and to the point. 1.2. What is the ratio of the % of repeaters in European Union in 1989 to that in 1993?
Provide a short and direct response. 1.07. What is the ratio of the % of repeaters of Heavily indebted poor countries in 1989 to that in 1993?
Make the answer very short. 0.98. What is the ratio of the % of repeaters of Iran in 1989 to that in 1993?
Keep it short and to the point. 0.98. What is the ratio of the % of repeaters of Qatar in 1989 to that in 1993?
Make the answer very short. 1.78. What is the ratio of the % of repeaters of European Union in 1989 to that in 1994?
Make the answer very short. 1.12. What is the ratio of the % of repeaters in Heavily indebted poor countries in 1989 to that in 1994?
Provide a succinct answer. 0.86. What is the ratio of the % of repeaters of Iran in 1989 to that in 1994?
Keep it short and to the point. 0.86. What is the ratio of the % of repeaters in Qatar in 1989 to that in 1994?
Give a very brief answer. 1.85. What is the ratio of the % of repeaters in European Union in 1990 to that in 1991?
Give a very brief answer. 1.01. What is the ratio of the % of repeaters in Heavily indebted poor countries in 1990 to that in 1991?
Make the answer very short. 0.96. What is the ratio of the % of repeaters of Qatar in 1990 to that in 1991?
Provide a succinct answer. 1.32. What is the ratio of the % of repeaters of European Union in 1990 to that in 1993?
Offer a very short reply. 1.02. What is the ratio of the % of repeaters in Heavily indebted poor countries in 1990 to that in 1993?
Your answer should be compact. 0.94. What is the ratio of the % of repeaters of Iran in 1990 to that in 1993?
Provide a succinct answer. 1.46. What is the ratio of the % of repeaters in Qatar in 1990 to that in 1993?
Offer a terse response. 1.95. What is the ratio of the % of repeaters of European Union in 1990 to that in 1994?
Ensure brevity in your answer.  1.07. What is the ratio of the % of repeaters in Heavily indebted poor countries in 1990 to that in 1994?
Ensure brevity in your answer.  0.82. What is the ratio of the % of repeaters in Iran in 1990 to that in 1994?
Offer a terse response. 1.28. What is the ratio of the % of repeaters of Qatar in 1990 to that in 1994?
Give a very brief answer. 2.03. What is the ratio of the % of repeaters in European Union in 1991 to that in 1993?
Ensure brevity in your answer.  1.01. What is the ratio of the % of repeaters in Heavily indebted poor countries in 1991 to that in 1993?
Keep it short and to the point. 0.98. What is the ratio of the % of repeaters in Iran in 1991 to that in 1993?
Ensure brevity in your answer.  1.47. What is the ratio of the % of repeaters of Qatar in 1991 to that in 1993?
Your answer should be compact. 1.48. What is the ratio of the % of repeaters in European Union in 1991 to that in 1994?
Your response must be concise. 1.06. What is the ratio of the % of repeaters of Heavily indebted poor countries in 1991 to that in 1994?
Your response must be concise. 0.86. What is the ratio of the % of repeaters in Iran in 1991 to that in 1994?
Offer a terse response. 1.29. What is the ratio of the % of repeaters in Qatar in 1991 to that in 1994?
Offer a very short reply. 1.54. What is the ratio of the % of repeaters in European Union in 1993 to that in 1994?
Offer a very short reply. 1.05. What is the ratio of the % of repeaters of Heavily indebted poor countries in 1993 to that in 1994?
Keep it short and to the point. 0.87. What is the ratio of the % of repeaters in Iran in 1993 to that in 1994?
Offer a very short reply. 0.87. What is the ratio of the % of repeaters in Qatar in 1993 to that in 1994?
Provide a short and direct response. 1.04. What is the difference between the highest and the second highest % of repeaters in European Union?
Keep it short and to the point. 0.3. What is the difference between the highest and the second highest % of repeaters of Heavily indebted poor countries?
Offer a very short reply. 1.53. What is the difference between the highest and the second highest % of repeaters in Iran?
Give a very brief answer. 2.06. What is the difference between the highest and the second highest % of repeaters of Qatar?
Make the answer very short. 6.4. What is the difference between the highest and the lowest % of repeaters in European Union?
Your response must be concise. 1.05. What is the difference between the highest and the lowest % of repeaters in Heavily indebted poor countries?
Offer a very short reply. 2.29. What is the difference between the highest and the lowest % of repeaters in Iran?
Make the answer very short. 7.57. What is the difference between the highest and the lowest % of repeaters in Qatar?
Make the answer very short. 15.08. 